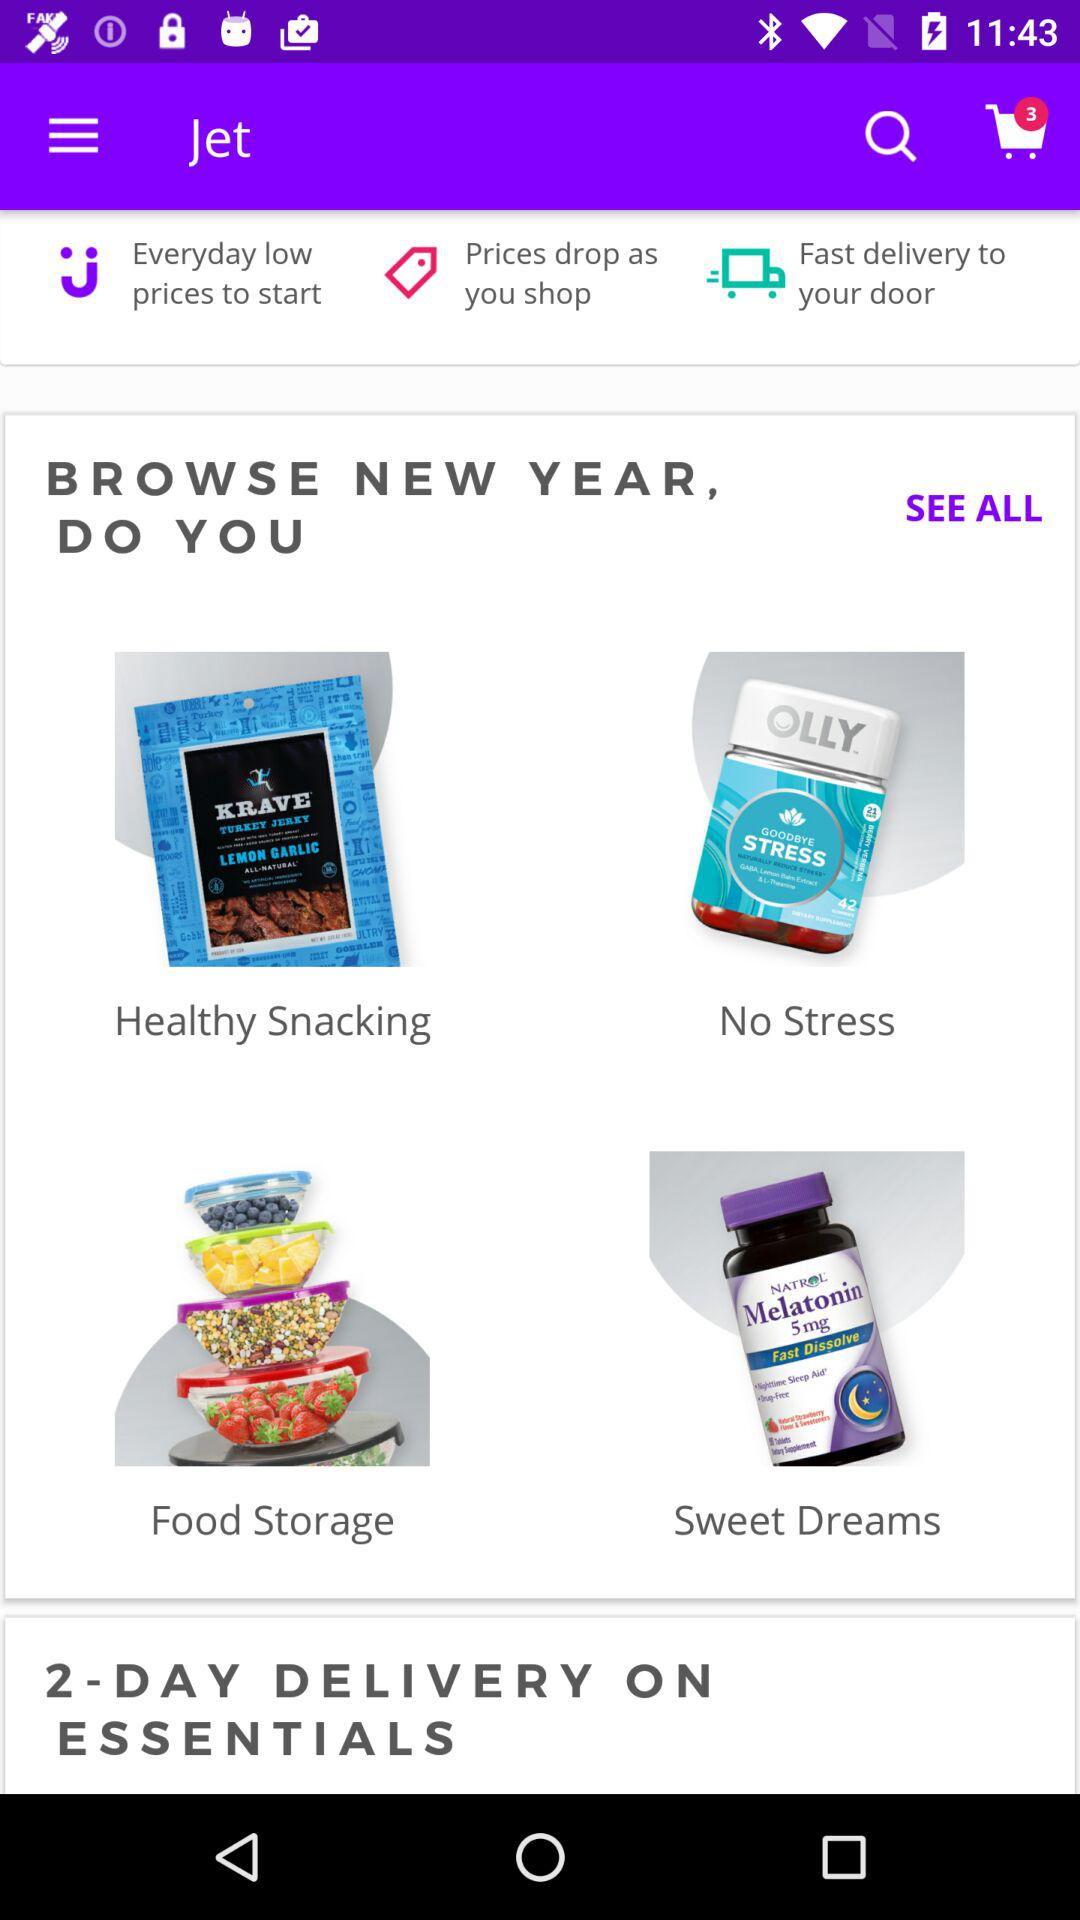What is the delivery time on essential products? The delivery time is 2 days. 